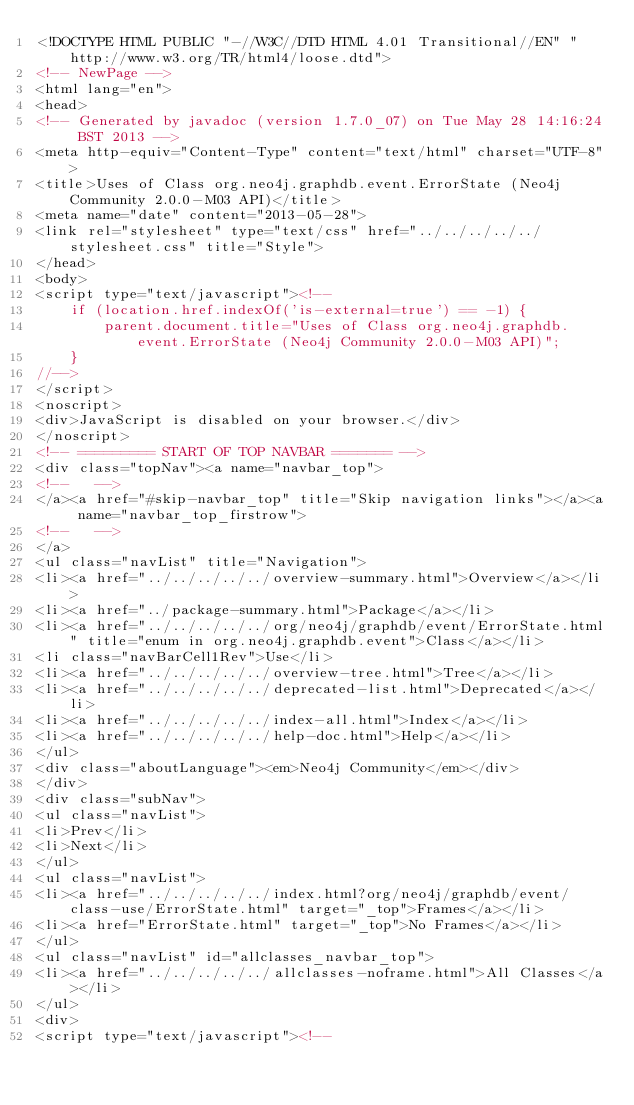Convert code to text. <code><loc_0><loc_0><loc_500><loc_500><_HTML_><!DOCTYPE HTML PUBLIC "-//W3C//DTD HTML 4.01 Transitional//EN" "http://www.w3.org/TR/html4/loose.dtd">
<!-- NewPage -->
<html lang="en">
<head>
<!-- Generated by javadoc (version 1.7.0_07) on Tue May 28 14:16:24 BST 2013 -->
<meta http-equiv="Content-Type" content="text/html" charset="UTF-8">
<title>Uses of Class org.neo4j.graphdb.event.ErrorState (Neo4j Community 2.0.0-M03 API)</title>
<meta name="date" content="2013-05-28">
<link rel="stylesheet" type="text/css" href="../../../../../stylesheet.css" title="Style">
</head>
<body>
<script type="text/javascript"><!--
    if (location.href.indexOf('is-external=true') == -1) {
        parent.document.title="Uses of Class org.neo4j.graphdb.event.ErrorState (Neo4j Community 2.0.0-M03 API)";
    }
//-->
</script>
<noscript>
<div>JavaScript is disabled on your browser.</div>
</noscript>
<!-- ========= START OF TOP NAVBAR ======= -->
<div class="topNav"><a name="navbar_top">
<!--   -->
</a><a href="#skip-navbar_top" title="Skip navigation links"></a><a name="navbar_top_firstrow">
<!--   -->
</a>
<ul class="navList" title="Navigation">
<li><a href="../../../../../overview-summary.html">Overview</a></li>
<li><a href="../package-summary.html">Package</a></li>
<li><a href="../../../../../org/neo4j/graphdb/event/ErrorState.html" title="enum in org.neo4j.graphdb.event">Class</a></li>
<li class="navBarCell1Rev">Use</li>
<li><a href="../../../../../overview-tree.html">Tree</a></li>
<li><a href="../../../../../deprecated-list.html">Deprecated</a></li>
<li><a href="../../../../../index-all.html">Index</a></li>
<li><a href="../../../../../help-doc.html">Help</a></li>
</ul>
<div class="aboutLanguage"><em>Neo4j Community</em></div>
</div>
<div class="subNav">
<ul class="navList">
<li>Prev</li>
<li>Next</li>
</ul>
<ul class="navList">
<li><a href="../../../../../index.html?org/neo4j/graphdb/event/class-use/ErrorState.html" target="_top">Frames</a></li>
<li><a href="ErrorState.html" target="_top">No Frames</a></li>
</ul>
<ul class="navList" id="allclasses_navbar_top">
<li><a href="../../../../../allclasses-noframe.html">All Classes</a></li>
</ul>
<div>
<script type="text/javascript"><!--</code> 